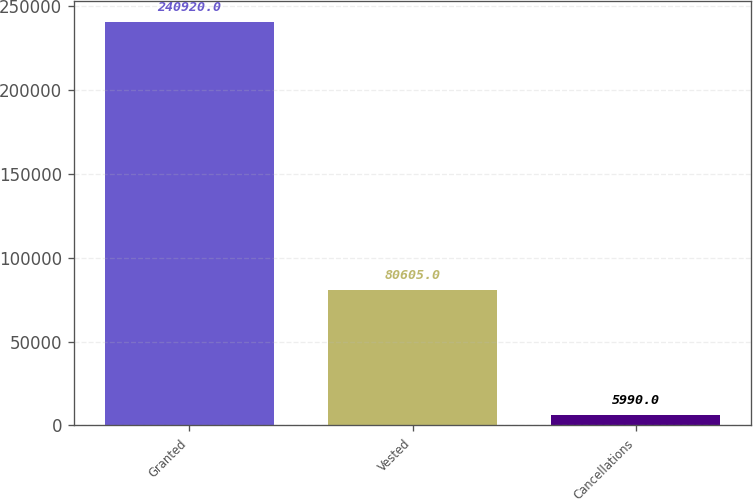<chart> <loc_0><loc_0><loc_500><loc_500><bar_chart><fcel>Granted<fcel>Vested<fcel>Cancellations<nl><fcel>240920<fcel>80605<fcel>5990<nl></chart> 